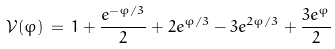<formula> <loc_0><loc_0><loc_500><loc_500>\mathcal { V } ( \varphi ) \, = \, 1 + \frac { e ^ { - \varphi / 3 } } { 2 } + 2 e ^ { \varphi / 3 } - 3 e ^ { 2 \varphi / 3 } + \frac { 3 e ^ { \varphi } } { 2 }</formula> 